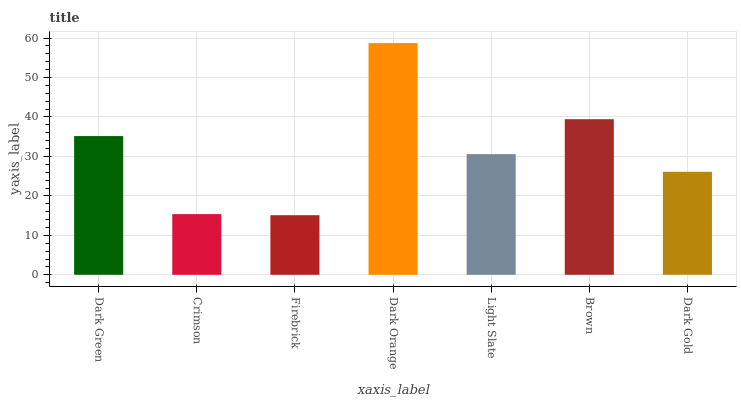Is Crimson the minimum?
Answer yes or no. No. Is Crimson the maximum?
Answer yes or no. No. Is Dark Green greater than Crimson?
Answer yes or no. Yes. Is Crimson less than Dark Green?
Answer yes or no. Yes. Is Crimson greater than Dark Green?
Answer yes or no. No. Is Dark Green less than Crimson?
Answer yes or no. No. Is Light Slate the high median?
Answer yes or no. Yes. Is Light Slate the low median?
Answer yes or no. Yes. Is Dark Gold the high median?
Answer yes or no. No. Is Dark Orange the low median?
Answer yes or no. No. 